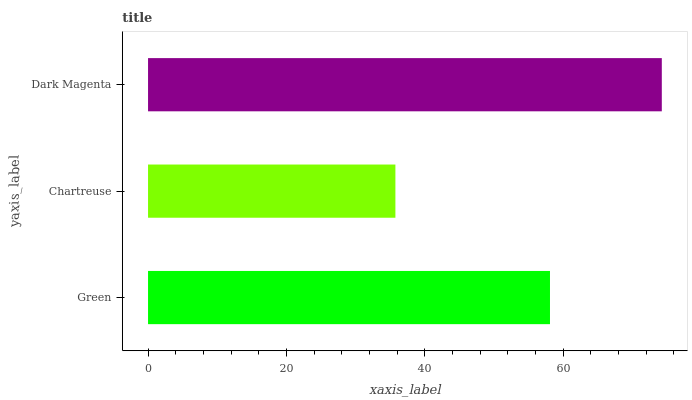Is Chartreuse the minimum?
Answer yes or no. Yes. Is Dark Magenta the maximum?
Answer yes or no. Yes. Is Dark Magenta the minimum?
Answer yes or no. No. Is Chartreuse the maximum?
Answer yes or no. No. Is Dark Magenta greater than Chartreuse?
Answer yes or no. Yes. Is Chartreuse less than Dark Magenta?
Answer yes or no. Yes. Is Chartreuse greater than Dark Magenta?
Answer yes or no. No. Is Dark Magenta less than Chartreuse?
Answer yes or no. No. Is Green the high median?
Answer yes or no. Yes. Is Green the low median?
Answer yes or no. Yes. Is Chartreuse the high median?
Answer yes or no. No. Is Dark Magenta the low median?
Answer yes or no. No. 